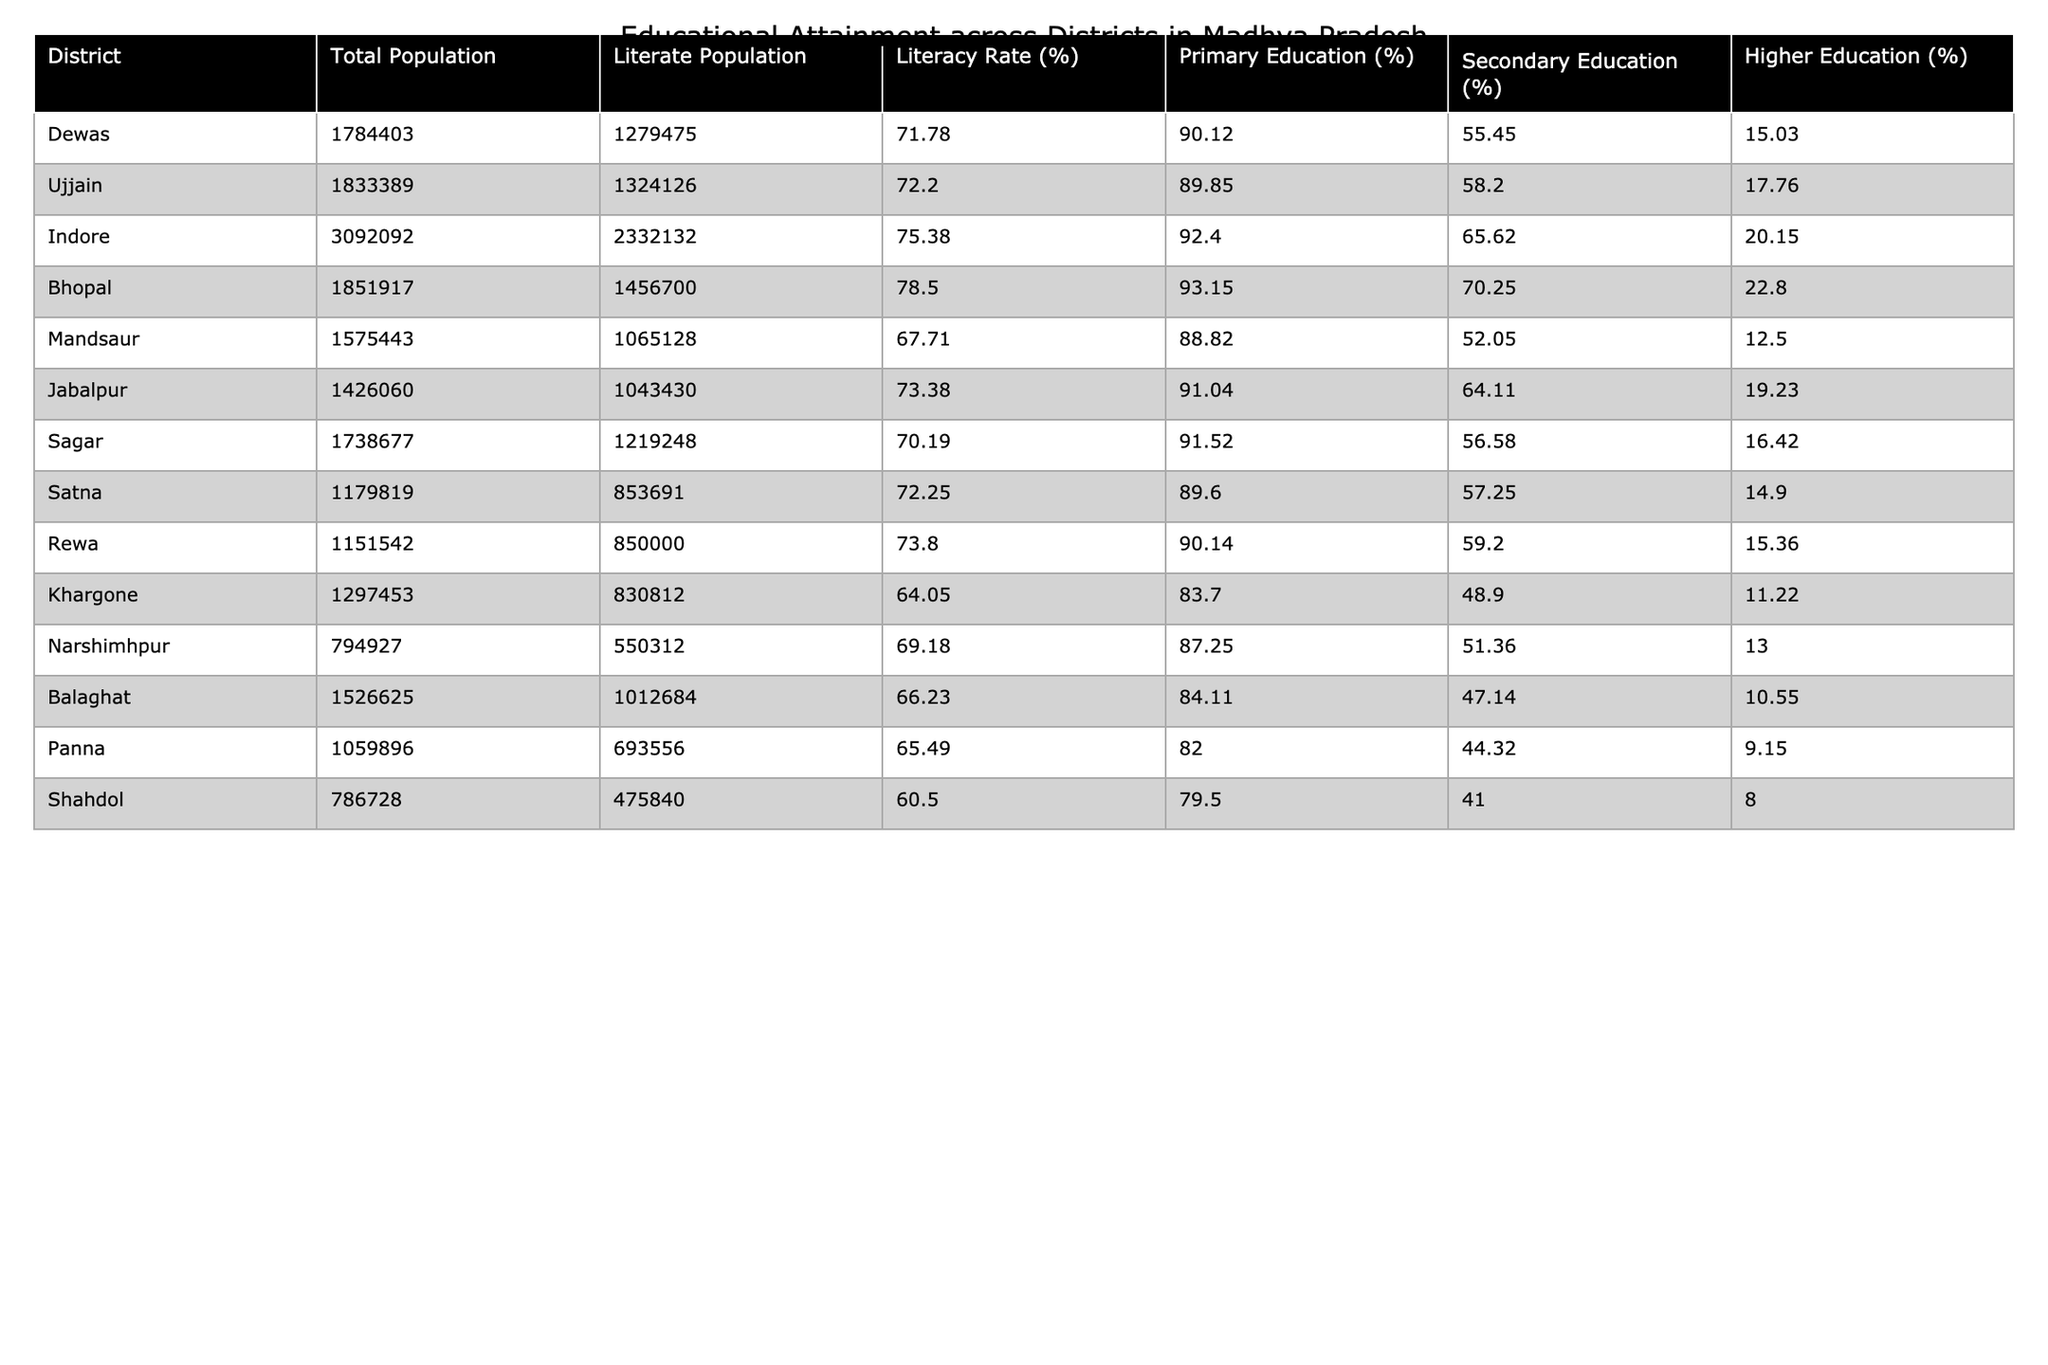What is the literacy rate in Indore? The literacy rate for Indore is presented directly in the table. By referring to the column for literacy rate, the value for Indore is 75.38%.
Answer: 75.38% Which district has the highest literacy rate? Looking at the literacy rates of all districts, Bhopal has the highest literacy rate of 78.50%.
Answer: Bhopal What percentage of the population in Dewas has higher education? The table shows that in Dewas, the percentage of the population with higher education is 15.03%.
Answer: 15.03% Calculate the average literacy rate of all the districts listed. Adding the literacy rates of each district: (71.78 + 72.20 + 75.38 + 78.50 + 67.71 + 73.38 + 70.19 + 72.25 + 73.80 + 64.05 + 69.18 + 66.23 + 65.49 + 60.50) = 1027.65. Then divide by the number of districts, which is 14. So, 1027.65 / 14 ≈ 73.4%.
Answer: 73.4% Is the literacy rate in Shahdol higher than that in Khargone? The literacy rate in Shahdol is 60.50% and in Khargone it is 64.05%. Since 60.50% is less than 64.05%, Shahdol's literacy rate is not higher.
Answer: No Which district has the lowest percentage of the population with secondary education? In the table, Balaghat shows the lowest percentage of the population with secondary education at 47.14%.
Answer: Balaghat What is the difference in higher education percentages between Bhopal and Mandsaur? Bhopal has a higher education percentage of 22.80% and Mandsaur has 12.50%. The difference is calculated as 22.80% - 12.50% = 10.30%.
Answer: 10.30% If you combine the populations of Panna and Shahdol, what is the total population? The total population for Panna is 1,059,896 and for Shahdol is 786,728. Adding these together gives: 1,059,896 + 786,728 = 1,846,624.
Answer: 1,846,624 Which two districts have the closest literacy rates? By examining the literacy rates, Ujjain (72.20%) and Satna (72.25%) have the closest rates. The difference is only 0.05%.
Answer: Ujjain and Satna Does any district have a literacy rate higher than 75%? Checking the literacy rates, Bhopal (78.50%), Indore (75.38%), and Ujjain (72.20%) show that Bhopal and Indore have rates above 75%, while Ujjain does not. Thus, it is true that some districts do have a literacy rate higher than 75%.
Answer: Yes What percentage of Indore's population has primary education? Referring to the table, the percentage of Indore's population with primary education is 92.40%.
Answer: 92.40% 